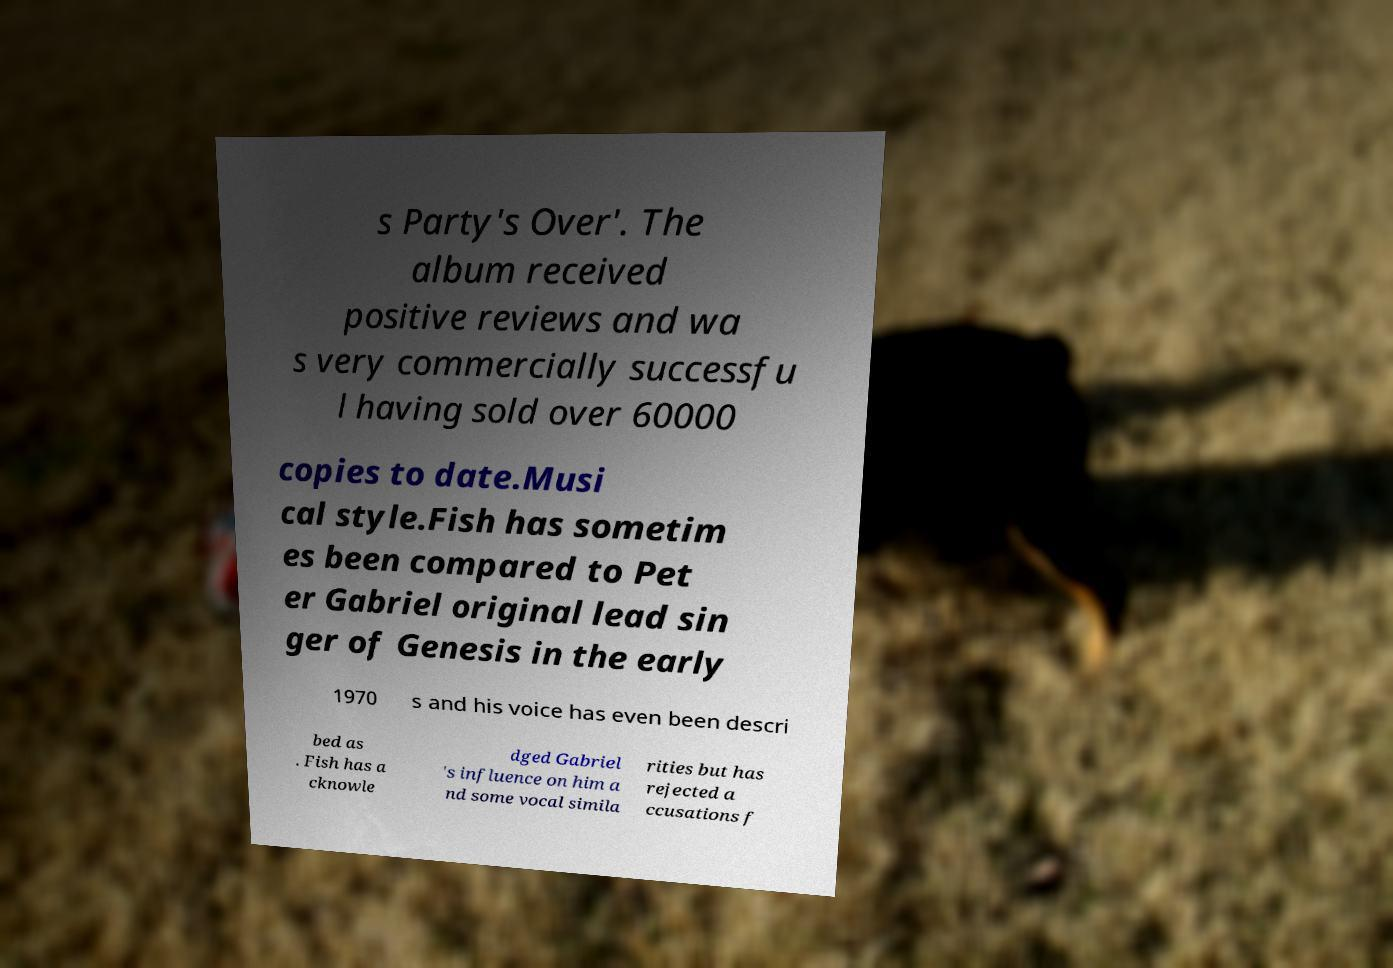Please identify and transcribe the text found in this image. s Party's Over'. The album received positive reviews and wa s very commercially successfu l having sold over 60000 copies to date.Musi cal style.Fish has sometim es been compared to Pet er Gabriel original lead sin ger of Genesis in the early 1970 s and his voice has even been descri bed as . Fish has a cknowle dged Gabriel 's influence on him a nd some vocal simila rities but has rejected a ccusations f 